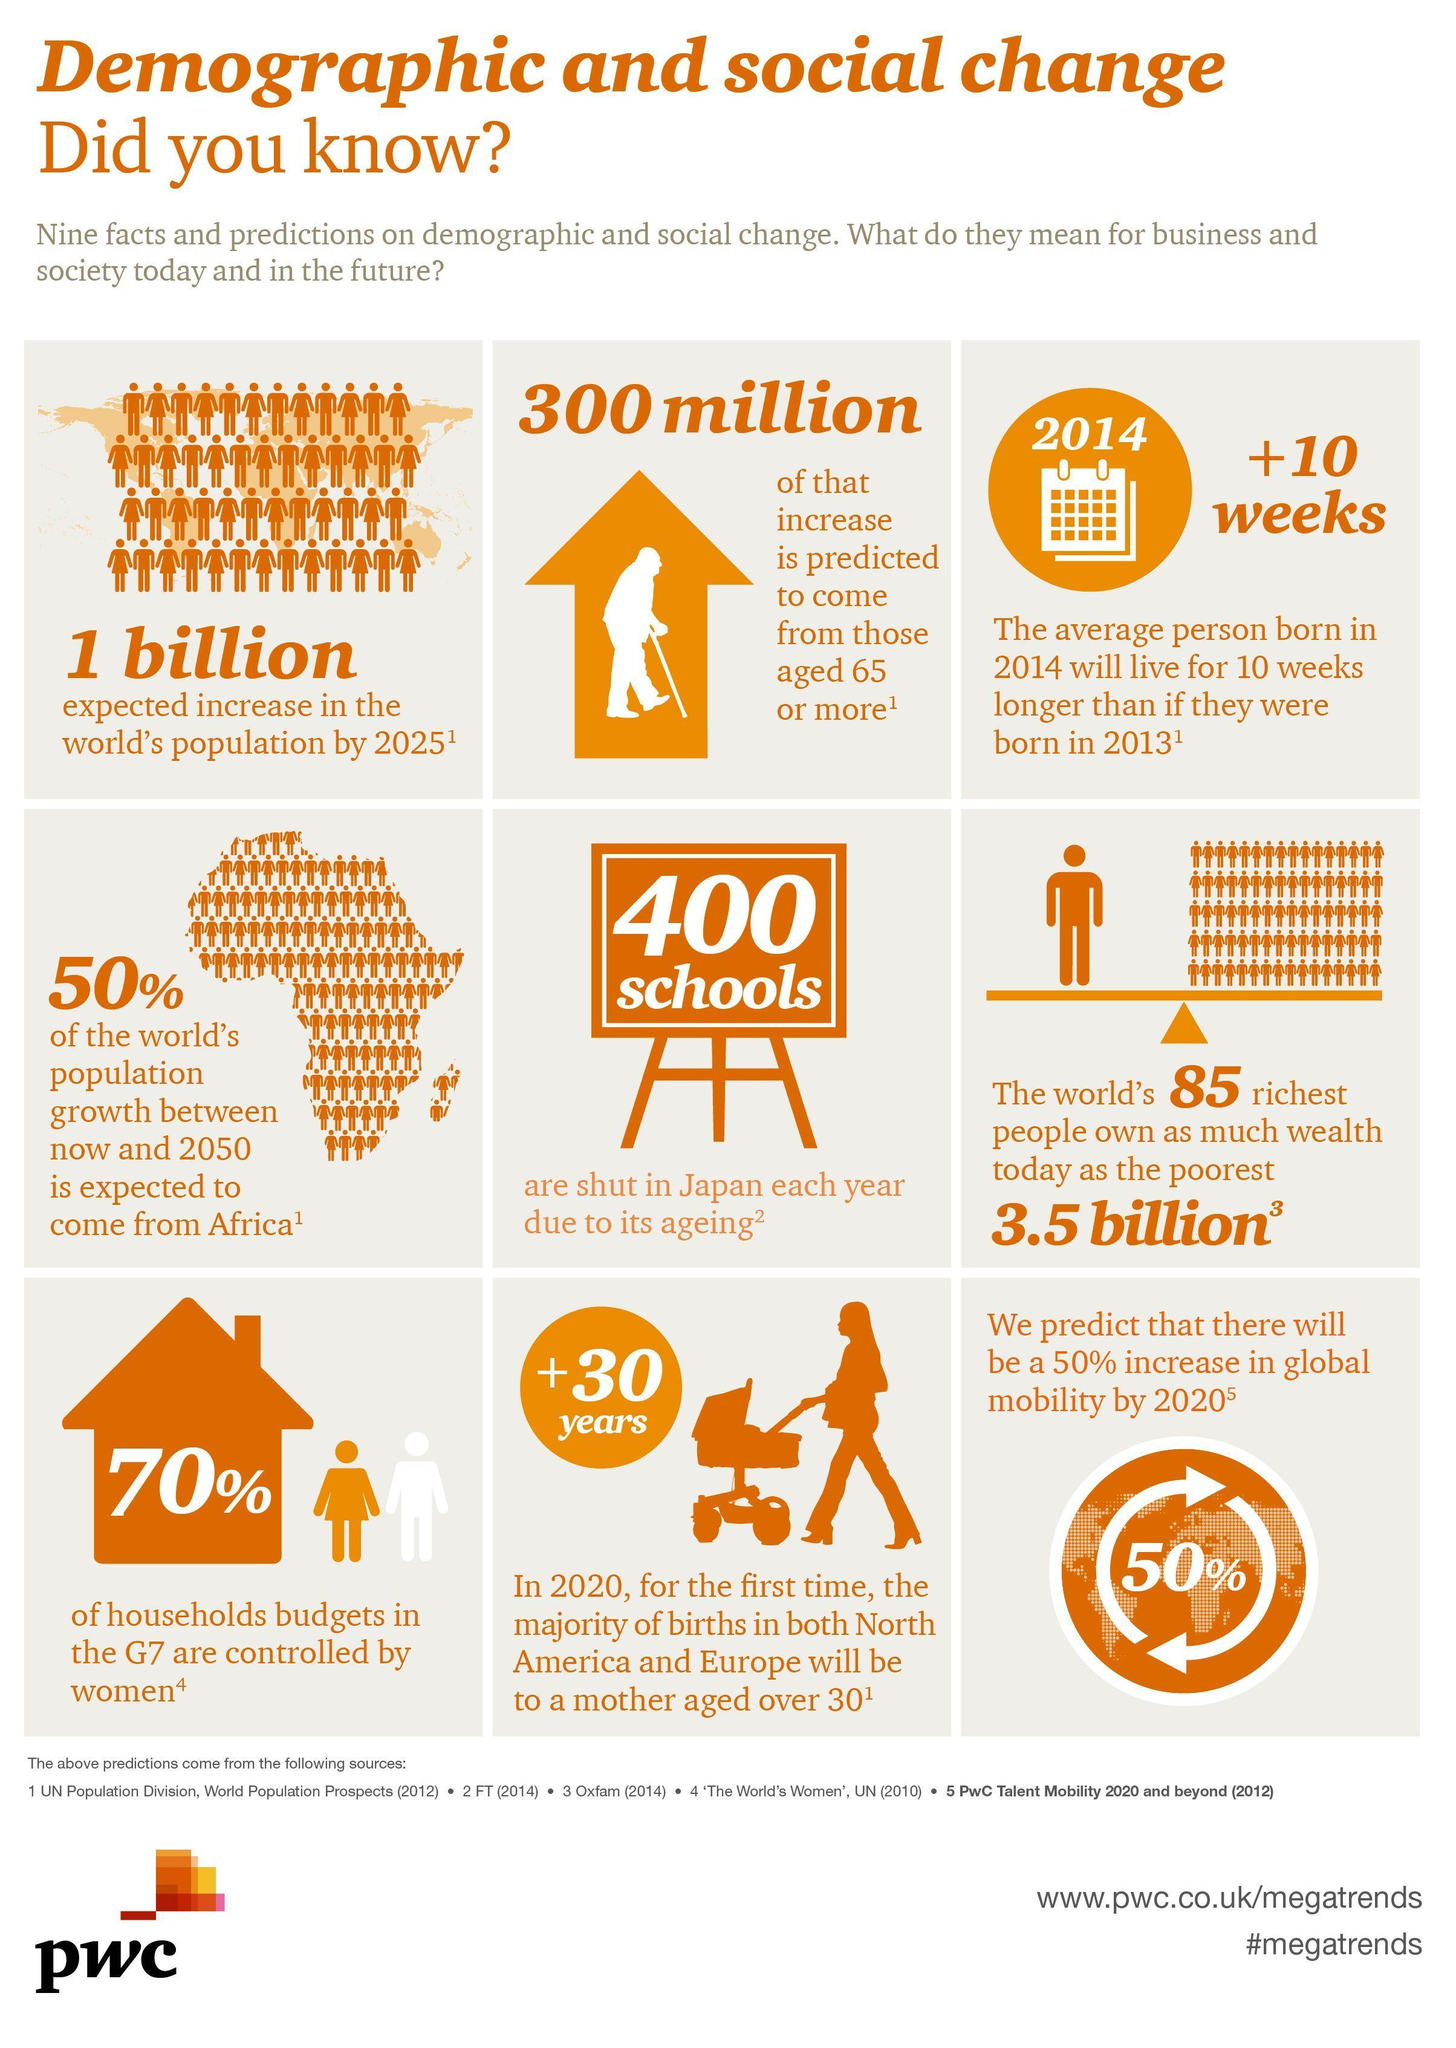What percentage of household budgets in G7 is not controlled by women?
Answer the question with a short phrase. 30% 